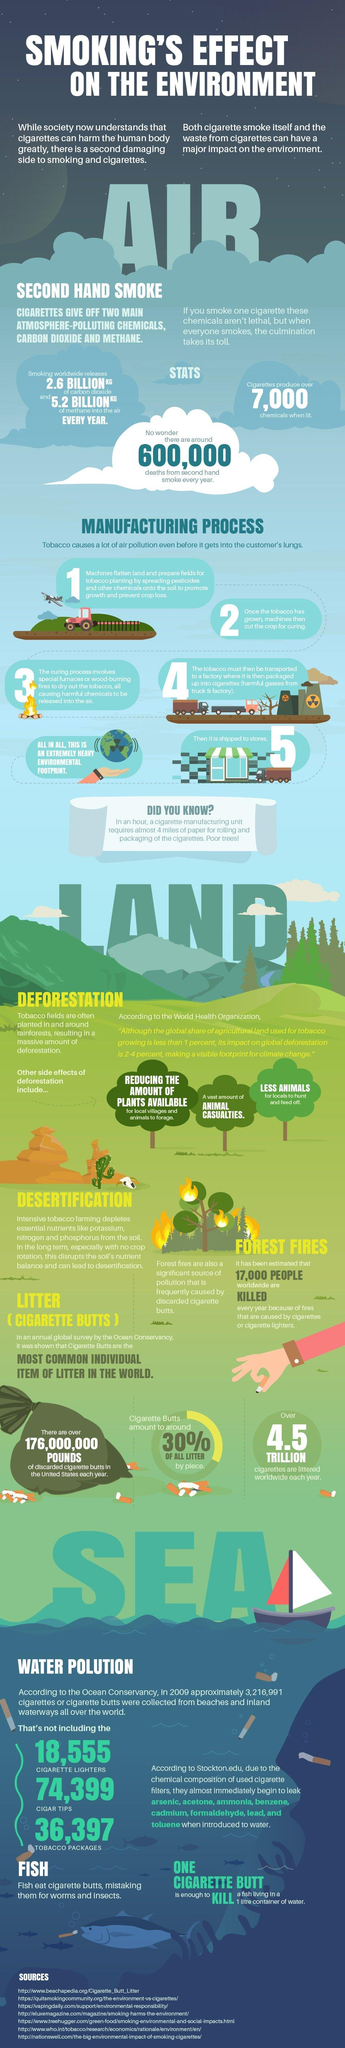Mention a couple of crucial points in this snapshot. There are seven sources listed at the bottom. 